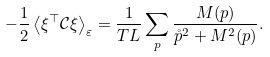Convert formula to latex. <formula><loc_0><loc_0><loc_500><loc_500>- \frac { 1 } { 2 } \left \langle \xi ^ { \top } \mathcal { C } \xi \right \rangle _ { \varepsilon } = \frac { 1 } { T L } \sum _ { p } \frac { M ( p ) } { \mathring { p } ^ { 2 } + M ^ { 2 } ( p ) } .</formula> 